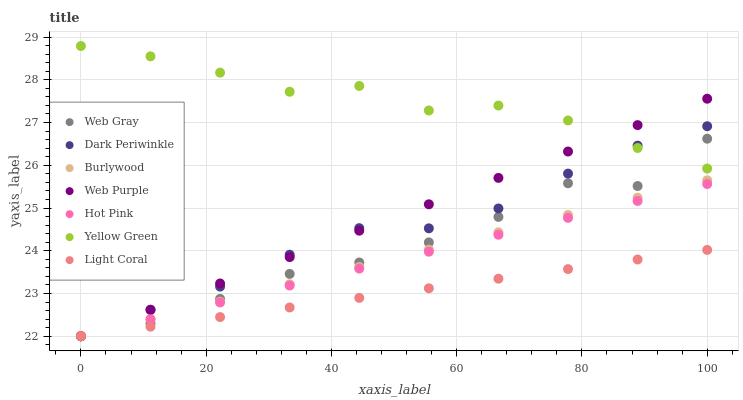Does Light Coral have the minimum area under the curve?
Answer yes or no. Yes. Does Yellow Green have the maximum area under the curve?
Answer yes or no. Yes. Does Burlywood have the minimum area under the curve?
Answer yes or no. No. Does Burlywood have the maximum area under the curve?
Answer yes or no. No. Is Hot Pink the smoothest?
Answer yes or no. Yes. Is Web Gray the roughest?
Answer yes or no. Yes. Is Yellow Green the smoothest?
Answer yes or no. No. Is Yellow Green the roughest?
Answer yes or no. No. Does Web Gray have the lowest value?
Answer yes or no. Yes. Does Yellow Green have the lowest value?
Answer yes or no. No. Does Yellow Green have the highest value?
Answer yes or no. Yes. Does Burlywood have the highest value?
Answer yes or no. No. Is Light Coral less than Yellow Green?
Answer yes or no. Yes. Is Yellow Green greater than Burlywood?
Answer yes or no. Yes. Does Dark Periwinkle intersect Burlywood?
Answer yes or no. Yes. Is Dark Periwinkle less than Burlywood?
Answer yes or no. No. Is Dark Periwinkle greater than Burlywood?
Answer yes or no. No. Does Light Coral intersect Yellow Green?
Answer yes or no. No. 